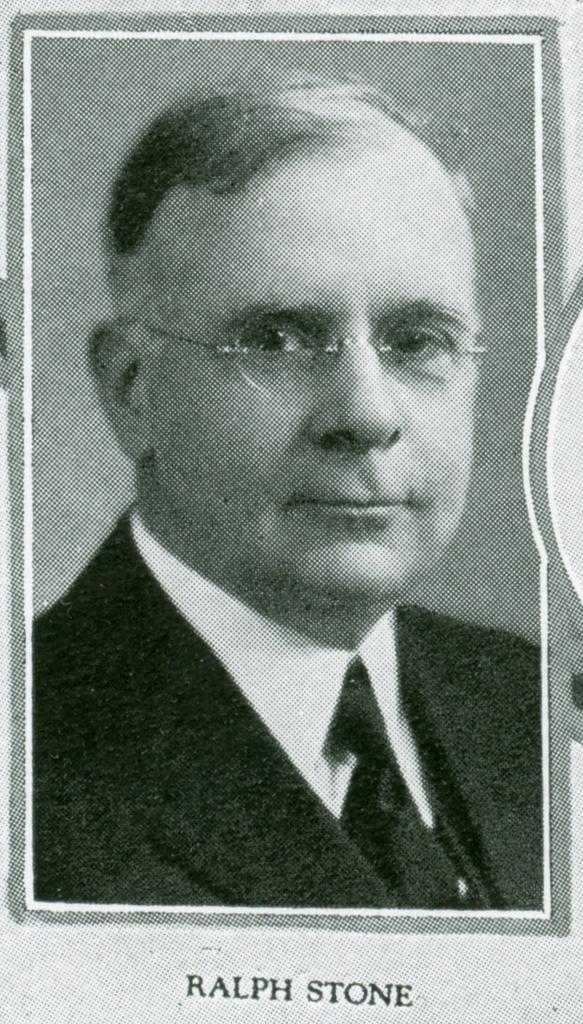Describe this image in one or two sentences. In this picture I can see the photo of a person. I can see text on it. 